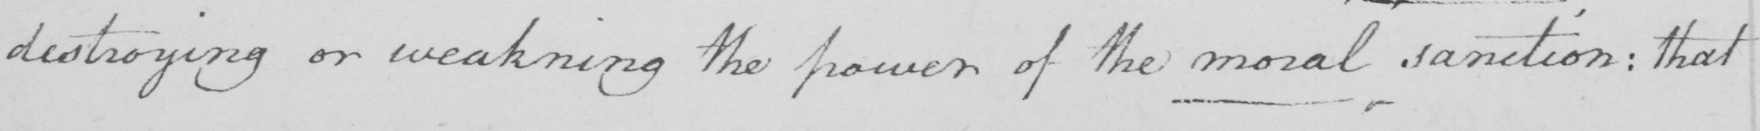What is written in this line of handwriting? destroying or weakning the power of the moral sanction :  that 